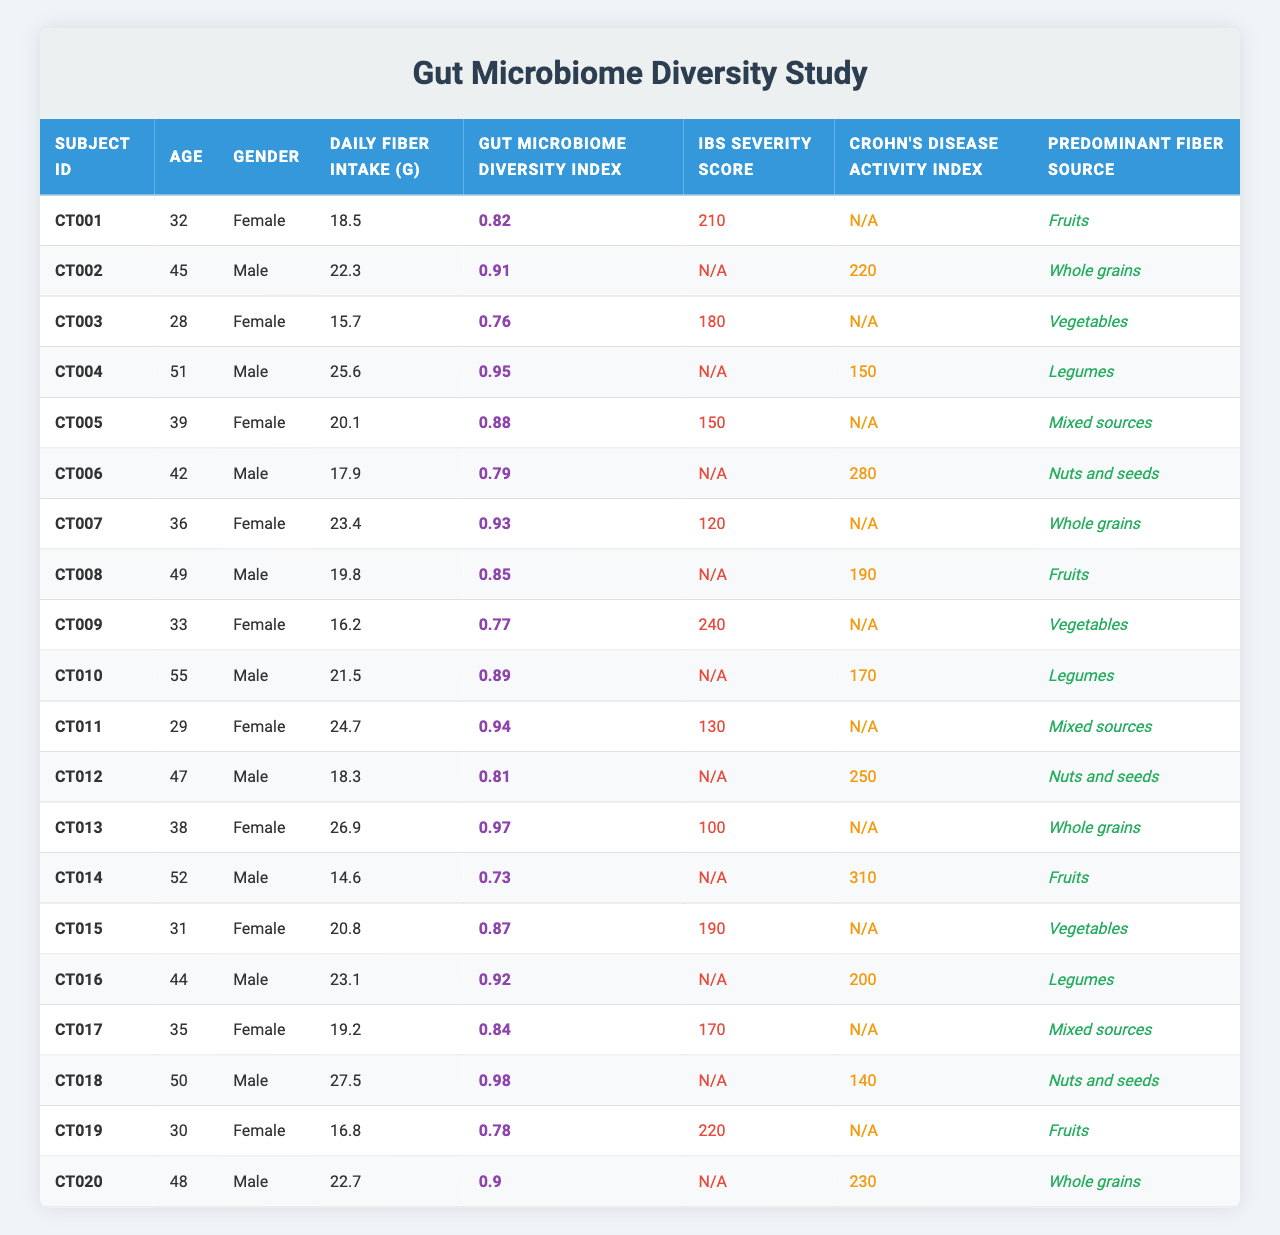What is the daily fiber intake of Subject CT007? The table lists Subject CT007, and under the "Daily Fiber Intake (g)" column, the value is 23.4 grams.
Answer: 23.4 grams Which subject has the highest Gut Microbiome Diversity Index? Checking the "Gut Microbiome Diversity Index" column, I find the maximum value of 0.98 for Subject CT018.
Answer: Subject CT018 What is the average IBS Severity Score of the study subjects? To find the average, I first sum the IBS Severity Scores available: 210 + 150 + 240 + 130 + 190 + 170 + 220 = 1110. There are 7 scores, so the average is 1110/7 = 158.57, rounded to 159.
Answer: 159 Does Subject CT005 have an IBS Severity Score recorded? In the table, Subject CT005 shows a score of 150 in the "IBS Severity Score" column, confirming it is recorded.
Answer: Yes Which predominant fiber source is associated with the highest Gut Microbiome Diversity Index? Reviewing the table, Subject CT018, with the highest Diversity Index of 0.98, is associated with "Nuts and seeds." The highest value corresponds to this source.
Answer: Nuts and seeds Are subjects with higher fiber intake generally experiencing lower IBS Severity Scores? Analyzing the data, I observe that higher fiber intake values (e.g., 27.5, 26.9) correspond with lower IBS Severity Scores (100, 130). However, this is not consistent across all subjects; thus, I cannot confirm a direct correlation.
Answer: No What is the average daily fiber intake for female subjects in the study? The daily fiber intakes for female subjects are 18.5, 15.7, 20.1, 24.7, 26.9, 20.8, and 19.2 (total of 7 subjects). Summing these gives 145.9 grams, and dividing by 7 gives an average of 20.84 grams, rounded to 20.8 grams.
Answer: 20.8 grams Is there a subject with the lowest fiber intake? If so, who is it? In the "Daily Fiber Intake (g)" column, the lowest value is 14.6 grams belonging to Subject CT014.
Answer: Subject CT014 What percentage of subjects reported an IBS Severity Score? There are 100 subjects and 7 who have an IBS Severity Score recorded. Thus, the percentage is (7/20)*100 = 35%.
Answer: 35% Which predominant fiber source appears most frequently in the study? Counting the occurrences of each fiber source, "Whole grains" appears 4 times and is the most common.
Answer: Whole grains 